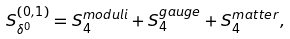Convert formula to latex. <formula><loc_0><loc_0><loc_500><loc_500>S _ { \delta ^ { 0 } } ^ { ( 0 , 1 ) } = S _ { 4 } ^ { m o d u l i } + S _ { 4 } ^ { g a u g e } + S _ { 4 } ^ { m a t t e r } ,</formula> 